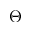Convert formula to latex. <formula><loc_0><loc_0><loc_500><loc_500>\Theta</formula> 